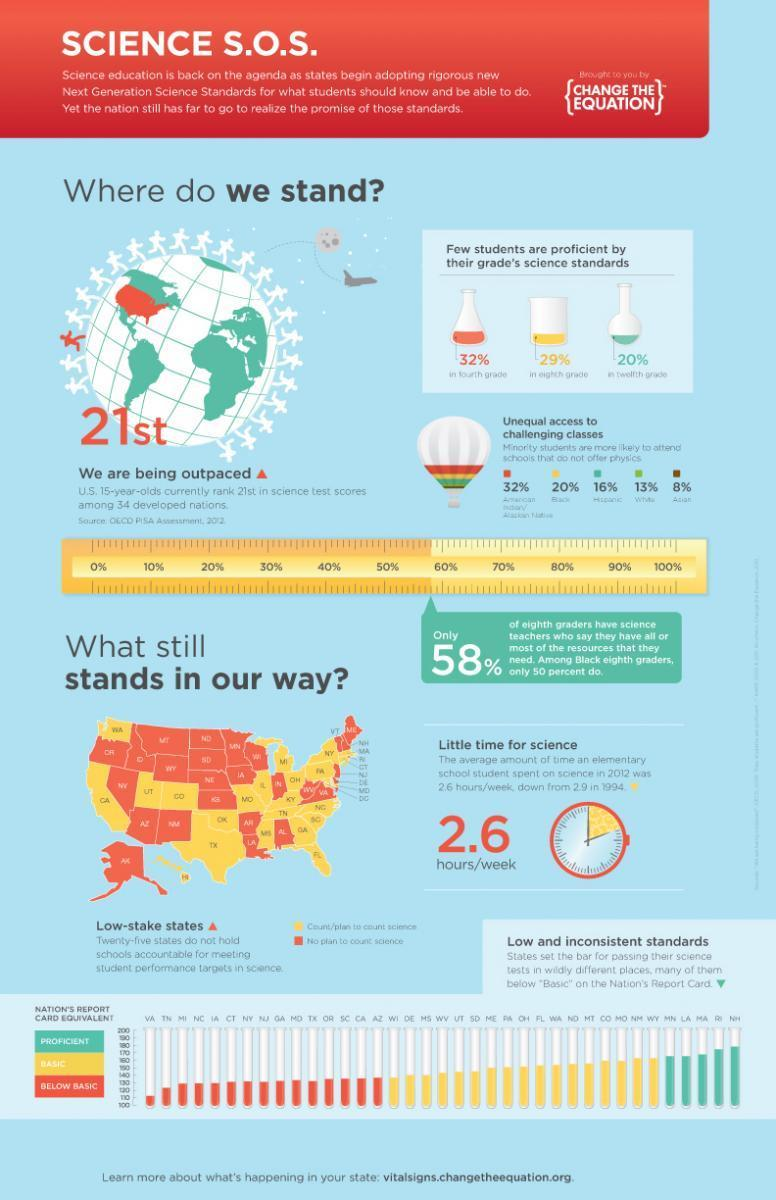What percentage of American students are proficient in their eight grade's science standards?
Answer the question with a short phrase. 29% What is the percentage of black students in America who are more likely to attend schools that do not offer physics? 20% What is the percentage of Asian students in America who are more likely to attend schools that do not offer physics? 8% What percentage of American students are proficient in their twelfth grade's science standards? 20% 